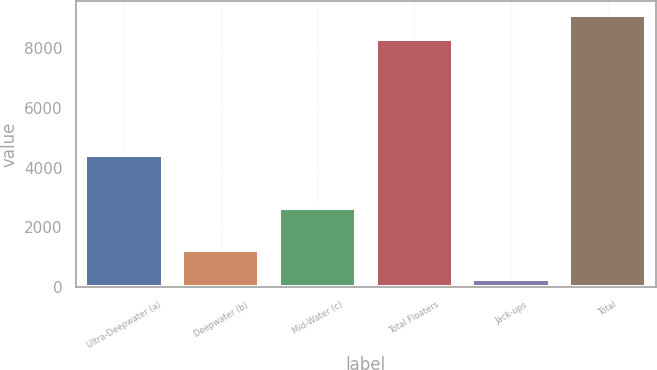<chart> <loc_0><loc_0><loc_500><loc_500><bar_chart><fcel>Ultra-Deepwater (a)<fcel>Deepwater (b)<fcel>Mid-Water (c)<fcel>Total Floaters<fcel>Jack-ups<fcel>Total<nl><fcel>4422<fcel>1229<fcel>2649<fcel>8300<fcel>272<fcel>9130<nl></chart> 